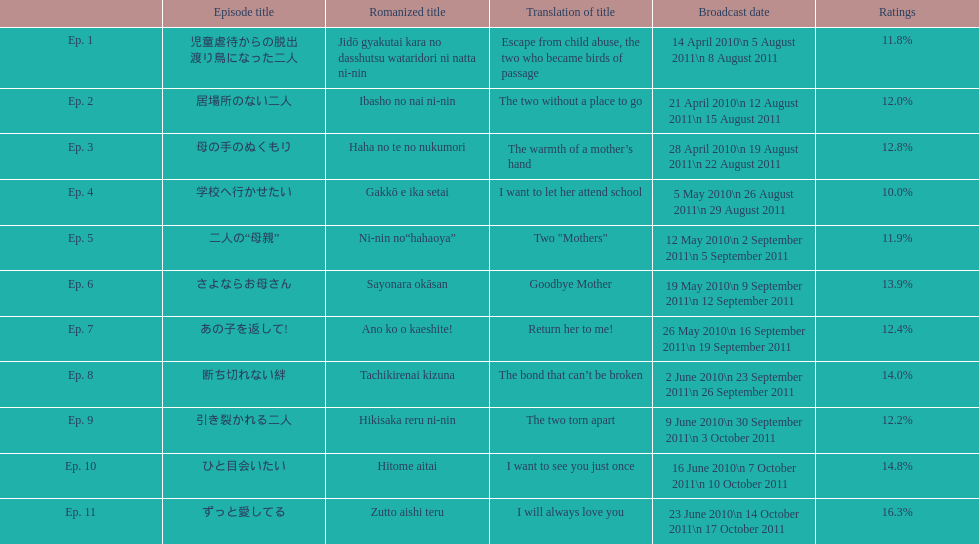In how many episodes is the percentage not exceeding 14%? 8. 